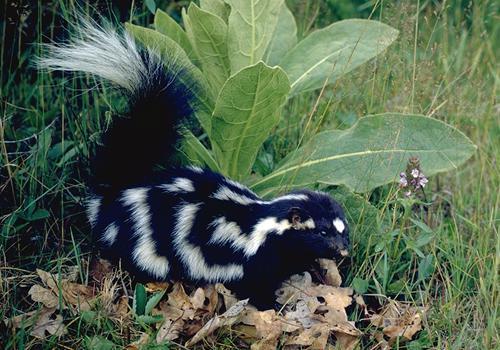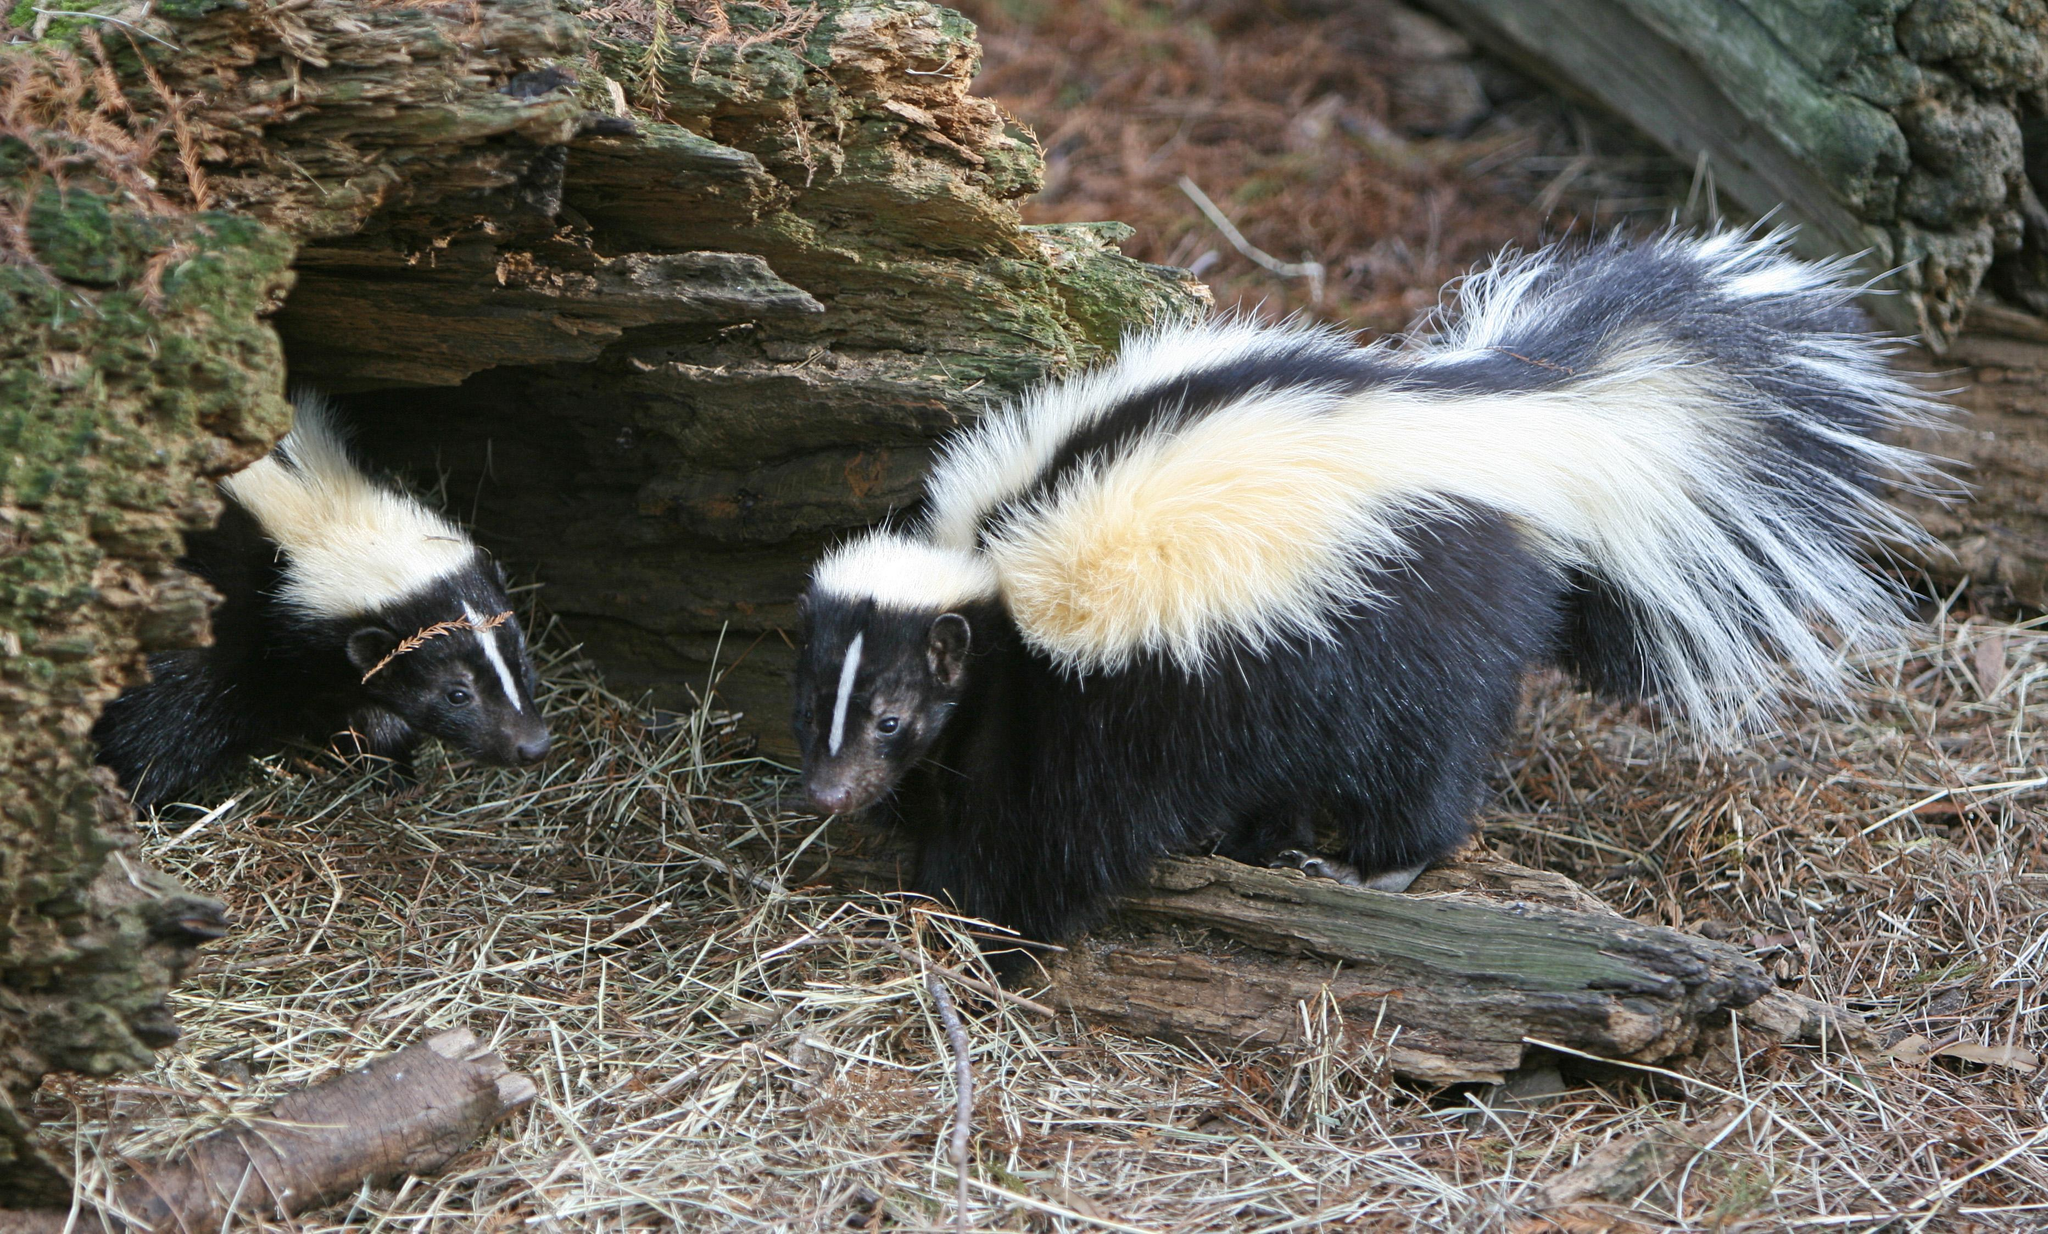The first image is the image on the left, the second image is the image on the right. Analyze the images presented: Is the assertion "One image contains twice as many skunks as the other image." valid? Answer yes or no. Yes. The first image is the image on the left, the second image is the image on the right. Considering the images on both sides, is "There are a total of exactly two skunks in the grass." valid? Answer yes or no. No. 